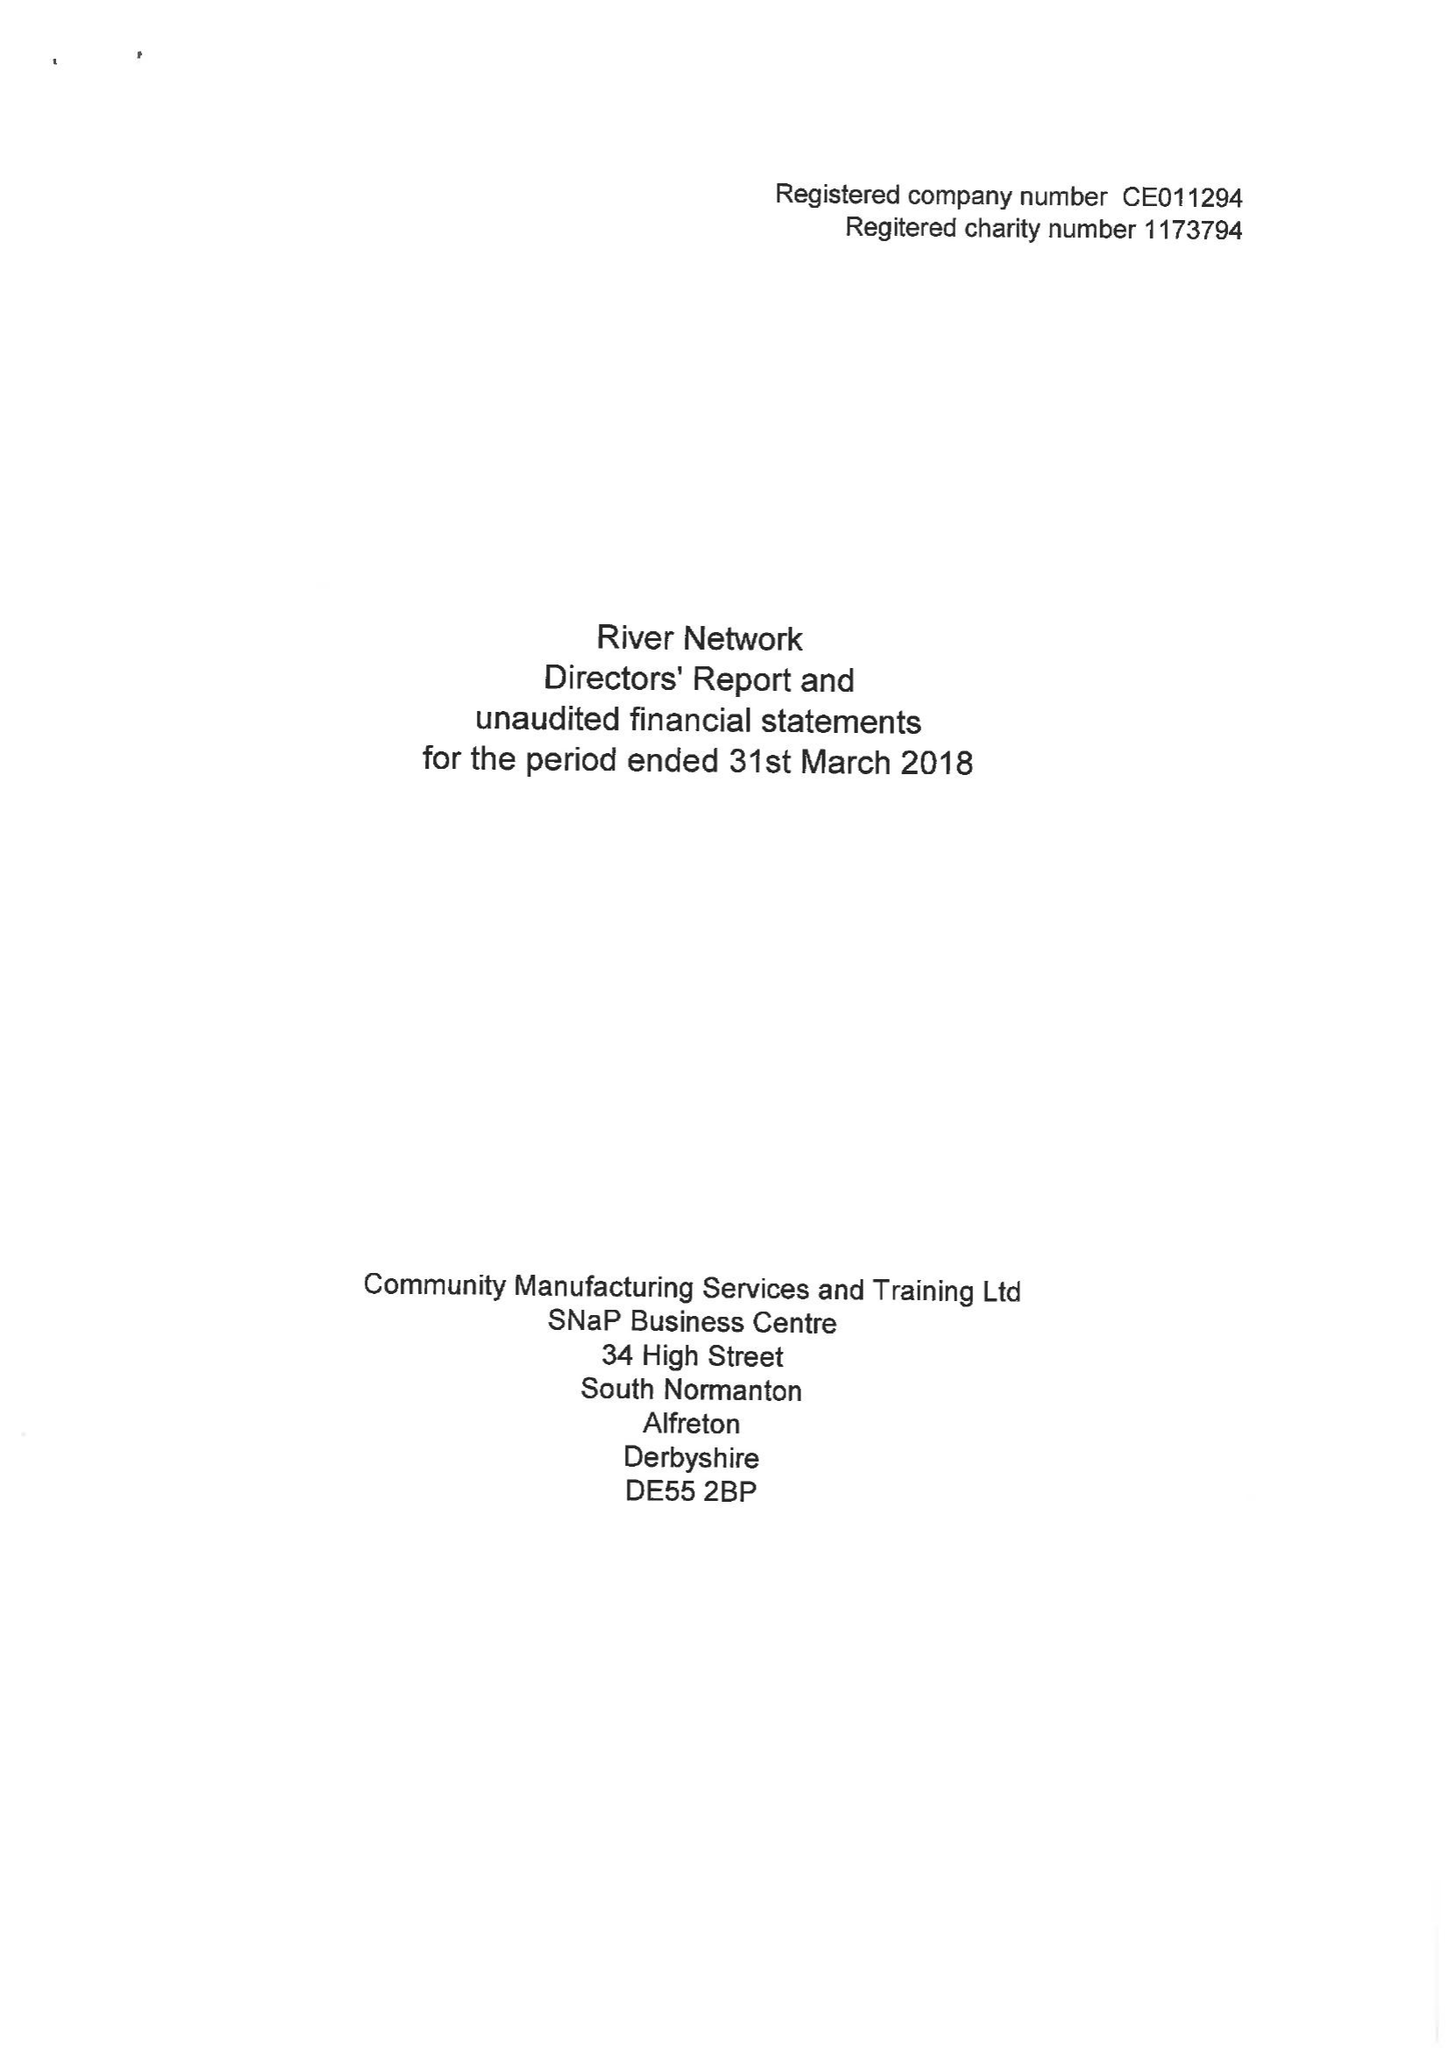What is the value for the income_annually_in_british_pounds?
Answer the question using a single word or phrase. 11062.00 